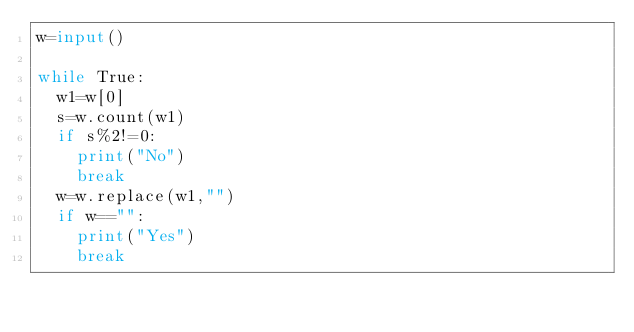Convert code to text. <code><loc_0><loc_0><loc_500><loc_500><_Python_>w=input()

while True:
  w1=w[0]
  s=w.count(w1)
  if s%2!=0:
    print("No")
    break
  w=w.replace(w1,"")
  if w=="":
    print("Yes")
    break</code> 